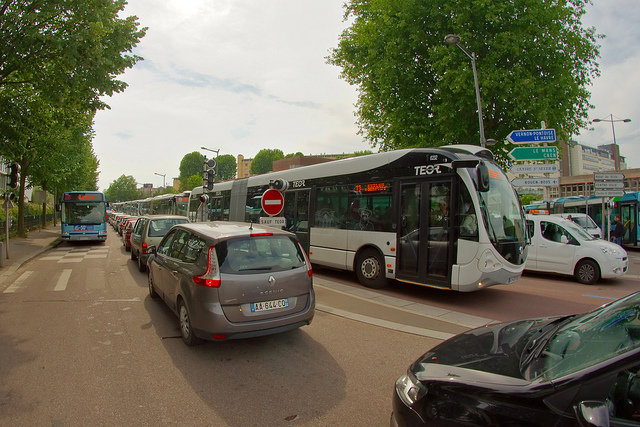Please identify all text content in this image. TEOR 